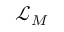Convert formula to latex. <formula><loc_0><loc_0><loc_500><loc_500>{ \mathcal { L } } _ { M }</formula> 